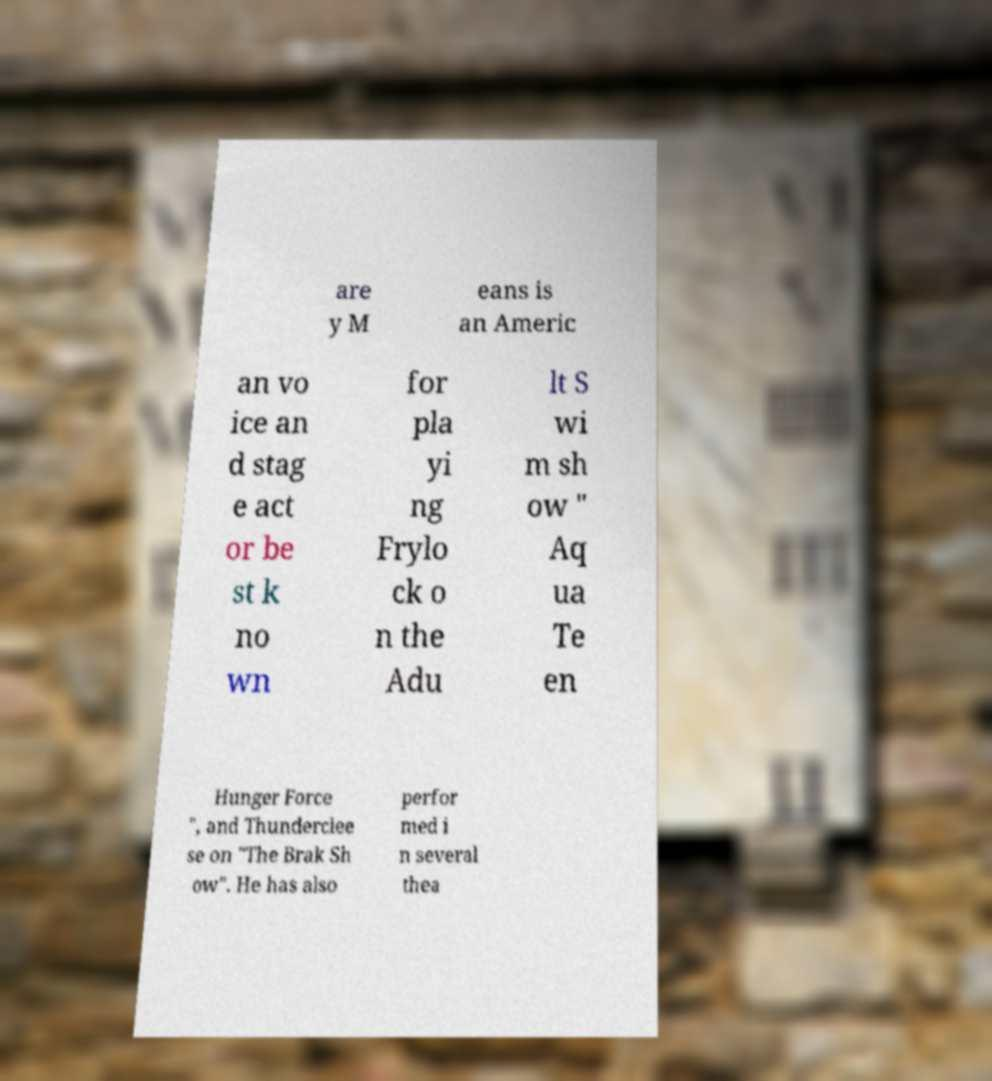Could you extract and type out the text from this image? are y M eans is an Americ an vo ice an d stag e act or be st k no wn for pla yi ng Frylo ck o n the Adu lt S wi m sh ow " Aq ua Te en Hunger Force ", and Thunderclee se on "The Brak Sh ow". He has also perfor med i n several thea 